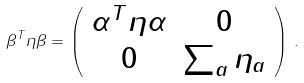Convert formula to latex. <formula><loc_0><loc_0><loc_500><loc_500>\beta ^ { T } \eta \beta = \left ( \begin{array} { c c } \alpha ^ { T } \eta \alpha & 0 \\ 0 & \sum _ { a } \eta _ { a } \end{array} \right ) \, .</formula> 